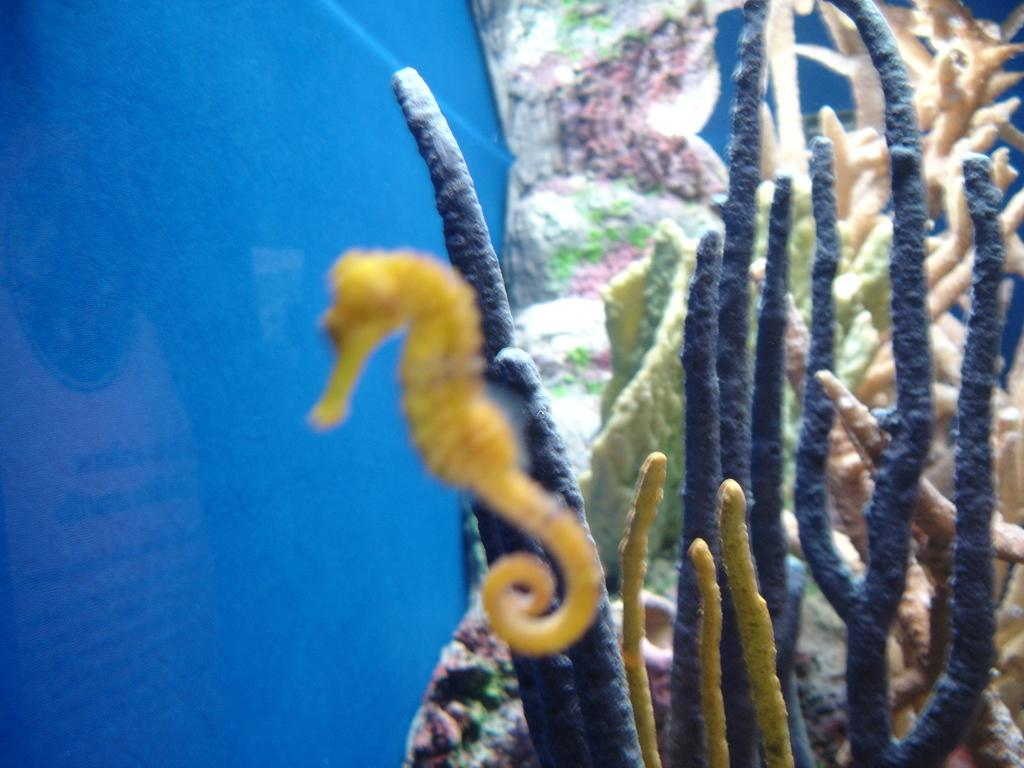What type of plants are in the image? There are water plants in the image. Where are the water plants located? The water plants are in the water. What type of sail can be seen on the goose in the image? There is no goose or sail present in the image; it features water plants in the water. What type of bulb is illuminating the water plants in the image? There is no bulb present in the image; the water plants are simply in the water. 